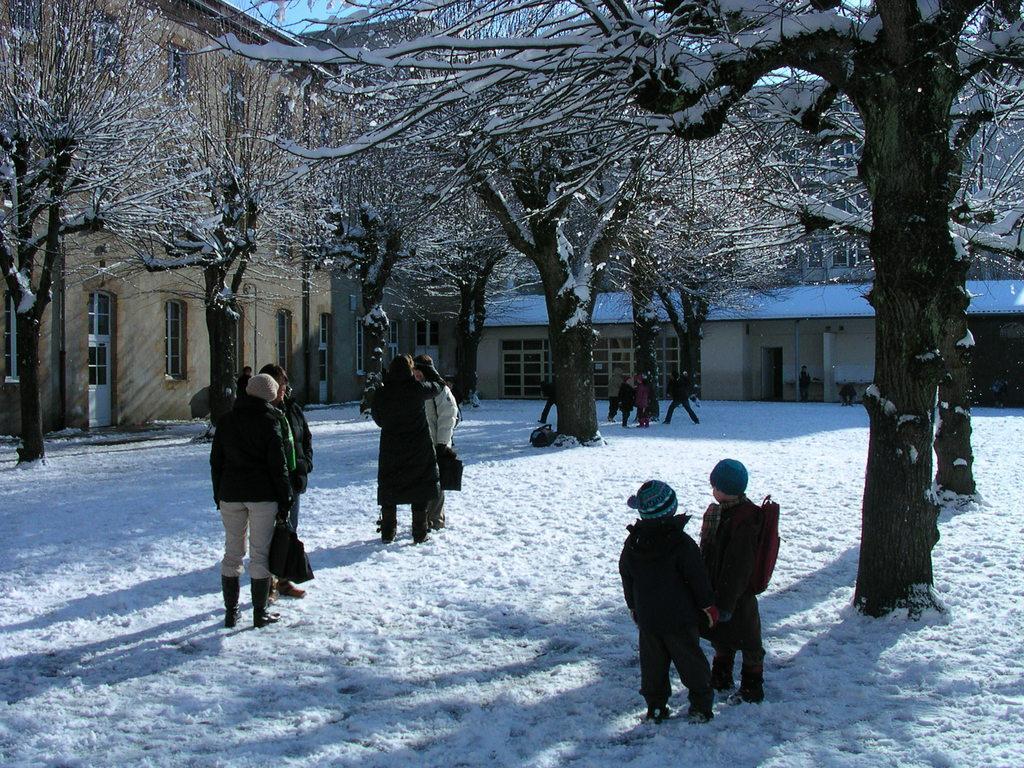Describe this image in one or two sentences. This picture describes about group of people, they are standing in the snow, few people are holding bags, in the background we can see few trees and houses. 